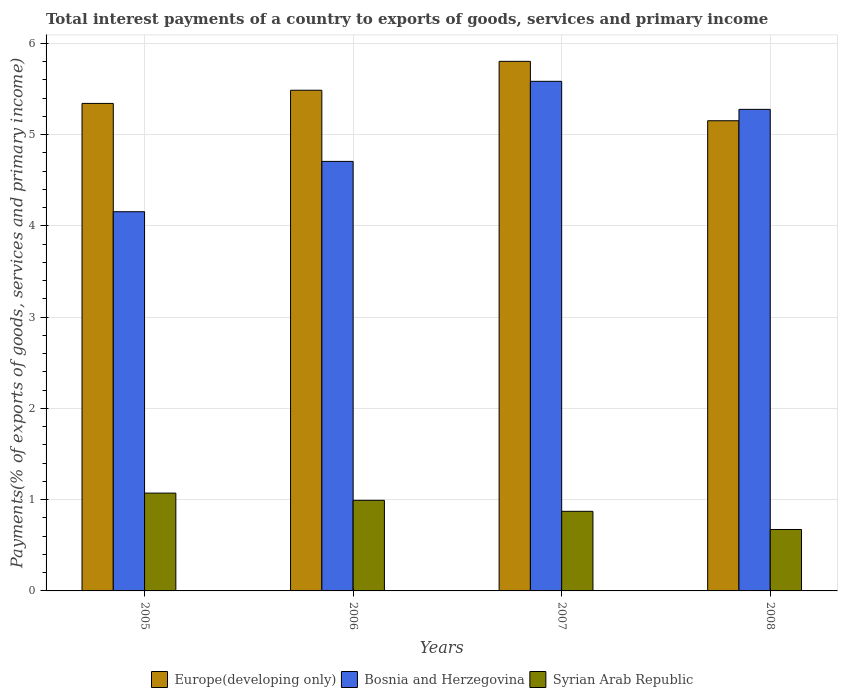Are the number of bars per tick equal to the number of legend labels?
Provide a short and direct response. Yes. How many bars are there on the 3rd tick from the right?
Keep it short and to the point. 3. What is the label of the 1st group of bars from the left?
Offer a terse response. 2005. What is the total interest payments in Syrian Arab Republic in 2005?
Give a very brief answer. 1.07. Across all years, what is the maximum total interest payments in Syrian Arab Republic?
Provide a short and direct response. 1.07. Across all years, what is the minimum total interest payments in Syrian Arab Republic?
Provide a short and direct response. 0.67. In which year was the total interest payments in Syrian Arab Republic maximum?
Offer a terse response. 2005. What is the total total interest payments in Syrian Arab Republic in the graph?
Give a very brief answer. 3.61. What is the difference between the total interest payments in Europe(developing only) in 2007 and that in 2008?
Your response must be concise. 0.65. What is the difference between the total interest payments in Europe(developing only) in 2007 and the total interest payments in Bosnia and Herzegovina in 2005?
Give a very brief answer. 1.65. What is the average total interest payments in Europe(developing only) per year?
Your response must be concise. 5.44. In the year 2008, what is the difference between the total interest payments in Syrian Arab Republic and total interest payments in Bosnia and Herzegovina?
Keep it short and to the point. -4.6. In how many years, is the total interest payments in Europe(developing only) greater than 3.4 %?
Give a very brief answer. 4. What is the ratio of the total interest payments in Europe(developing only) in 2005 to that in 2008?
Your response must be concise. 1.04. Is the total interest payments in Bosnia and Herzegovina in 2007 less than that in 2008?
Your response must be concise. No. Is the difference between the total interest payments in Syrian Arab Republic in 2006 and 2008 greater than the difference between the total interest payments in Bosnia and Herzegovina in 2006 and 2008?
Make the answer very short. Yes. What is the difference between the highest and the second highest total interest payments in Syrian Arab Republic?
Keep it short and to the point. 0.08. What is the difference between the highest and the lowest total interest payments in Bosnia and Herzegovina?
Provide a succinct answer. 1.43. In how many years, is the total interest payments in Syrian Arab Republic greater than the average total interest payments in Syrian Arab Republic taken over all years?
Offer a very short reply. 2. Is the sum of the total interest payments in Europe(developing only) in 2005 and 2008 greater than the maximum total interest payments in Bosnia and Herzegovina across all years?
Ensure brevity in your answer.  Yes. What does the 2nd bar from the left in 2005 represents?
Offer a terse response. Bosnia and Herzegovina. What does the 2nd bar from the right in 2006 represents?
Make the answer very short. Bosnia and Herzegovina. How many bars are there?
Provide a succinct answer. 12. How many years are there in the graph?
Provide a succinct answer. 4. Does the graph contain grids?
Keep it short and to the point. Yes. How are the legend labels stacked?
Offer a very short reply. Horizontal. What is the title of the graph?
Your answer should be compact. Total interest payments of a country to exports of goods, services and primary income. What is the label or title of the X-axis?
Provide a succinct answer. Years. What is the label or title of the Y-axis?
Offer a very short reply. Payments(% of exports of goods, services and primary income). What is the Payments(% of exports of goods, services and primary income) in Europe(developing only) in 2005?
Offer a terse response. 5.34. What is the Payments(% of exports of goods, services and primary income) of Bosnia and Herzegovina in 2005?
Your answer should be compact. 4.15. What is the Payments(% of exports of goods, services and primary income) in Syrian Arab Republic in 2005?
Offer a terse response. 1.07. What is the Payments(% of exports of goods, services and primary income) in Europe(developing only) in 2006?
Provide a short and direct response. 5.49. What is the Payments(% of exports of goods, services and primary income) in Bosnia and Herzegovina in 2006?
Make the answer very short. 4.71. What is the Payments(% of exports of goods, services and primary income) of Syrian Arab Republic in 2006?
Your answer should be compact. 0.99. What is the Payments(% of exports of goods, services and primary income) of Europe(developing only) in 2007?
Provide a short and direct response. 5.8. What is the Payments(% of exports of goods, services and primary income) of Bosnia and Herzegovina in 2007?
Your answer should be compact. 5.58. What is the Payments(% of exports of goods, services and primary income) in Syrian Arab Republic in 2007?
Provide a short and direct response. 0.87. What is the Payments(% of exports of goods, services and primary income) in Europe(developing only) in 2008?
Provide a short and direct response. 5.15. What is the Payments(% of exports of goods, services and primary income) in Bosnia and Herzegovina in 2008?
Keep it short and to the point. 5.28. What is the Payments(% of exports of goods, services and primary income) in Syrian Arab Republic in 2008?
Provide a succinct answer. 0.67. Across all years, what is the maximum Payments(% of exports of goods, services and primary income) in Europe(developing only)?
Provide a succinct answer. 5.8. Across all years, what is the maximum Payments(% of exports of goods, services and primary income) of Bosnia and Herzegovina?
Offer a very short reply. 5.58. Across all years, what is the maximum Payments(% of exports of goods, services and primary income) in Syrian Arab Republic?
Your answer should be very brief. 1.07. Across all years, what is the minimum Payments(% of exports of goods, services and primary income) in Europe(developing only)?
Your answer should be compact. 5.15. Across all years, what is the minimum Payments(% of exports of goods, services and primary income) in Bosnia and Herzegovina?
Provide a succinct answer. 4.15. Across all years, what is the minimum Payments(% of exports of goods, services and primary income) of Syrian Arab Republic?
Offer a very short reply. 0.67. What is the total Payments(% of exports of goods, services and primary income) of Europe(developing only) in the graph?
Make the answer very short. 21.78. What is the total Payments(% of exports of goods, services and primary income) of Bosnia and Herzegovina in the graph?
Your answer should be compact. 19.72. What is the total Payments(% of exports of goods, services and primary income) of Syrian Arab Republic in the graph?
Provide a succinct answer. 3.61. What is the difference between the Payments(% of exports of goods, services and primary income) in Europe(developing only) in 2005 and that in 2006?
Offer a terse response. -0.14. What is the difference between the Payments(% of exports of goods, services and primary income) in Bosnia and Herzegovina in 2005 and that in 2006?
Your answer should be compact. -0.55. What is the difference between the Payments(% of exports of goods, services and primary income) of Syrian Arab Republic in 2005 and that in 2006?
Offer a terse response. 0.08. What is the difference between the Payments(% of exports of goods, services and primary income) of Europe(developing only) in 2005 and that in 2007?
Offer a very short reply. -0.46. What is the difference between the Payments(% of exports of goods, services and primary income) in Bosnia and Herzegovina in 2005 and that in 2007?
Provide a short and direct response. -1.43. What is the difference between the Payments(% of exports of goods, services and primary income) in Syrian Arab Republic in 2005 and that in 2007?
Your answer should be very brief. 0.2. What is the difference between the Payments(% of exports of goods, services and primary income) in Europe(developing only) in 2005 and that in 2008?
Make the answer very short. 0.19. What is the difference between the Payments(% of exports of goods, services and primary income) of Bosnia and Herzegovina in 2005 and that in 2008?
Provide a succinct answer. -1.12. What is the difference between the Payments(% of exports of goods, services and primary income) in Syrian Arab Republic in 2005 and that in 2008?
Offer a very short reply. 0.4. What is the difference between the Payments(% of exports of goods, services and primary income) in Europe(developing only) in 2006 and that in 2007?
Your answer should be very brief. -0.32. What is the difference between the Payments(% of exports of goods, services and primary income) in Bosnia and Herzegovina in 2006 and that in 2007?
Offer a very short reply. -0.88. What is the difference between the Payments(% of exports of goods, services and primary income) in Syrian Arab Republic in 2006 and that in 2007?
Your answer should be compact. 0.12. What is the difference between the Payments(% of exports of goods, services and primary income) in Europe(developing only) in 2006 and that in 2008?
Ensure brevity in your answer.  0.33. What is the difference between the Payments(% of exports of goods, services and primary income) of Bosnia and Herzegovina in 2006 and that in 2008?
Offer a very short reply. -0.57. What is the difference between the Payments(% of exports of goods, services and primary income) of Syrian Arab Republic in 2006 and that in 2008?
Your response must be concise. 0.32. What is the difference between the Payments(% of exports of goods, services and primary income) of Europe(developing only) in 2007 and that in 2008?
Make the answer very short. 0.65. What is the difference between the Payments(% of exports of goods, services and primary income) of Bosnia and Herzegovina in 2007 and that in 2008?
Your answer should be very brief. 0.31. What is the difference between the Payments(% of exports of goods, services and primary income) of Syrian Arab Republic in 2007 and that in 2008?
Provide a short and direct response. 0.2. What is the difference between the Payments(% of exports of goods, services and primary income) in Europe(developing only) in 2005 and the Payments(% of exports of goods, services and primary income) in Bosnia and Herzegovina in 2006?
Your answer should be compact. 0.64. What is the difference between the Payments(% of exports of goods, services and primary income) of Europe(developing only) in 2005 and the Payments(% of exports of goods, services and primary income) of Syrian Arab Republic in 2006?
Your response must be concise. 4.35. What is the difference between the Payments(% of exports of goods, services and primary income) of Bosnia and Herzegovina in 2005 and the Payments(% of exports of goods, services and primary income) of Syrian Arab Republic in 2006?
Offer a terse response. 3.16. What is the difference between the Payments(% of exports of goods, services and primary income) in Europe(developing only) in 2005 and the Payments(% of exports of goods, services and primary income) in Bosnia and Herzegovina in 2007?
Ensure brevity in your answer.  -0.24. What is the difference between the Payments(% of exports of goods, services and primary income) in Europe(developing only) in 2005 and the Payments(% of exports of goods, services and primary income) in Syrian Arab Republic in 2007?
Your answer should be very brief. 4.47. What is the difference between the Payments(% of exports of goods, services and primary income) in Bosnia and Herzegovina in 2005 and the Payments(% of exports of goods, services and primary income) in Syrian Arab Republic in 2007?
Ensure brevity in your answer.  3.28. What is the difference between the Payments(% of exports of goods, services and primary income) of Europe(developing only) in 2005 and the Payments(% of exports of goods, services and primary income) of Bosnia and Herzegovina in 2008?
Make the answer very short. 0.07. What is the difference between the Payments(% of exports of goods, services and primary income) of Europe(developing only) in 2005 and the Payments(% of exports of goods, services and primary income) of Syrian Arab Republic in 2008?
Your response must be concise. 4.67. What is the difference between the Payments(% of exports of goods, services and primary income) in Bosnia and Herzegovina in 2005 and the Payments(% of exports of goods, services and primary income) in Syrian Arab Republic in 2008?
Give a very brief answer. 3.48. What is the difference between the Payments(% of exports of goods, services and primary income) of Europe(developing only) in 2006 and the Payments(% of exports of goods, services and primary income) of Bosnia and Herzegovina in 2007?
Your answer should be very brief. -0.1. What is the difference between the Payments(% of exports of goods, services and primary income) of Europe(developing only) in 2006 and the Payments(% of exports of goods, services and primary income) of Syrian Arab Republic in 2007?
Provide a succinct answer. 4.61. What is the difference between the Payments(% of exports of goods, services and primary income) of Bosnia and Herzegovina in 2006 and the Payments(% of exports of goods, services and primary income) of Syrian Arab Republic in 2007?
Make the answer very short. 3.83. What is the difference between the Payments(% of exports of goods, services and primary income) of Europe(developing only) in 2006 and the Payments(% of exports of goods, services and primary income) of Bosnia and Herzegovina in 2008?
Offer a terse response. 0.21. What is the difference between the Payments(% of exports of goods, services and primary income) in Europe(developing only) in 2006 and the Payments(% of exports of goods, services and primary income) in Syrian Arab Republic in 2008?
Keep it short and to the point. 4.81. What is the difference between the Payments(% of exports of goods, services and primary income) in Bosnia and Herzegovina in 2006 and the Payments(% of exports of goods, services and primary income) in Syrian Arab Republic in 2008?
Provide a succinct answer. 4.03. What is the difference between the Payments(% of exports of goods, services and primary income) of Europe(developing only) in 2007 and the Payments(% of exports of goods, services and primary income) of Bosnia and Herzegovina in 2008?
Offer a terse response. 0.53. What is the difference between the Payments(% of exports of goods, services and primary income) of Europe(developing only) in 2007 and the Payments(% of exports of goods, services and primary income) of Syrian Arab Republic in 2008?
Offer a very short reply. 5.13. What is the difference between the Payments(% of exports of goods, services and primary income) in Bosnia and Herzegovina in 2007 and the Payments(% of exports of goods, services and primary income) in Syrian Arab Republic in 2008?
Ensure brevity in your answer.  4.91. What is the average Payments(% of exports of goods, services and primary income) of Europe(developing only) per year?
Offer a very short reply. 5.44. What is the average Payments(% of exports of goods, services and primary income) of Bosnia and Herzegovina per year?
Your response must be concise. 4.93. What is the average Payments(% of exports of goods, services and primary income) of Syrian Arab Republic per year?
Give a very brief answer. 0.9. In the year 2005, what is the difference between the Payments(% of exports of goods, services and primary income) of Europe(developing only) and Payments(% of exports of goods, services and primary income) of Bosnia and Herzegovina?
Your answer should be compact. 1.19. In the year 2005, what is the difference between the Payments(% of exports of goods, services and primary income) of Europe(developing only) and Payments(% of exports of goods, services and primary income) of Syrian Arab Republic?
Your answer should be compact. 4.27. In the year 2005, what is the difference between the Payments(% of exports of goods, services and primary income) of Bosnia and Herzegovina and Payments(% of exports of goods, services and primary income) of Syrian Arab Republic?
Your answer should be compact. 3.08. In the year 2006, what is the difference between the Payments(% of exports of goods, services and primary income) of Europe(developing only) and Payments(% of exports of goods, services and primary income) of Bosnia and Herzegovina?
Your answer should be very brief. 0.78. In the year 2006, what is the difference between the Payments(% of exports of goods, services and primary income) of Europe(developing only) and Payments(% of exports of goods, services and primary income) of Syrian Arab Republic?
Offer a terse response. 4.49. In the year 2006, what is the difference between the Payments(% of exports of goods, services and primary income) of Bosnia and Herzegovina and Payments(% of exports of goods, services and primary income) of Syrian Arab Republic?
Keep it short and to the point. 3.71. In the year 2007, what is the difference between the Payments(% of exports of goods, services and primary income) in Europe(developing only) and Payments(% of exports of goods, services and primary income) in Bosnia and Herzegovina?
Keep it short and to the point. 0.22. In the year 2007, what is the difference between the Payments(% of exports of goods, services and primary income) in Europe(developing only) and Payments(% of exports of goods, services and primary income) in Syrian Arab Republic?
Offer a terse response. 4.93. In the year 2007, what is the difference between the Payments(% of exports of goods, services and primary income) of Bosnia and Herzegovina and Payments(% of exports of goods, services and primary income) of Syrian Arab Republic?
Offer a terse response. 4.71. In the year 2008, what is the difference between the Payments(% of exports of goods, services and primary income) of Europe(developing only) and Payments(% of exports of goods, services and primary income) of Bosnia and Herzegovina?
Provide a short and direct response. -0.12. In the year 2008, what is the difference between the Payments(% of exports of goods, services and primary income) in Europe(developing only) and Payments(% of exports of goods, services and primary income) in Syrian Arab Republic?
Your answer should be very brief. 4.48. In the year 2008, what is the difference between the Payments(% of exports of goods, services and primary income) in Bosnia and Herzegovina and Payments(% of exports of goods, services and primary income) in Syrian Arab Republic?
Offer a terse response. 4.6. What is the ratio of the Payments(% of exports of goods, services and primary income) of Europe(developing only) in 2005 to that in 2006?
Your answer should be compact. 0.97. What is the ratio of the Payments(% of exports of goods, services and primary income) in Bosnia and Herzegovina in 2005 to that in 2006?
Offer a very short reply. 0.88. What is the ratio of the Payments(% of exports of goods, services and primary income) in Syrian Arab Republic in 2005 to that in 2006?
Provide a short and direct response. 1.08. What is the ratio of the Payments(% of exports of goods, services and primary income) in Europe(developing only) in 2005 to that in 2007?
Make the answer very short. 0.92. What is the ratio of the Payments(% of exports of goods, services and primary income) of Bosnia and Herzegovina in 2005 to that in 2007?
Keep it short and to the point. 0.74. What is the ratio of the Payments(% of exports of goods, services and primary income) of Syrian Arab Republic in 2005 to that in 2007?
Keep it short and to the point. 1.23. What is the ratio of the Payments(% of exports of goods, services and primary income) of Europe(developing only) in 2005 to that in 2008?
Keep it short and to the point. 1.04. What is the ratio of the Payments(% of exports of goods, services and primary income) in Bosnia and Herzegovina in 2005 to that in 2008?
Give a very brief answer. 0.79. What is the ratio of the Payments(% of exports of goods, services and primary income) in Syrian Arab Republic in 2005 to that in 2008?
Your answer should be compact. 1.59. What is the ratio of the Payments(% of exports of goods, services and primary income) in Europe(developing only) in 2006 to that in 2007?
Your answer should be compact. 0.95. What is the ratio of the Payments(% of exports of goods, services and primary income) of Bosnia and Herzegovina in 2006 to that in 2007?
Offer a terse response. 0.84. What is the ratio of the Payments(% of exports of goods, services and primary income) in Syrian Arab Republic in 2006 to that in 2007?
Provide a short and direct response. 1.14. What is the ratio of the Payments(% of exports of goods, services and primary income) of Europe(developing only) in 2006 to that in 2008?
Offer a terse response. 1.06. What is the ratio of the Payments(% of exports of goods, services and primary income) of Bosnia and Herzegovina in 2006 to that in 2008?
Your answer should be compact. 0.89. What is the ratio of the Payments(% of exports of goods, services and primary income) of Syrian Arab Republic in 2006 to that in 2008?
Give a very brief answer. 1.48. What is the ratio of the Payments(% of exports of goods, services and primary income) in Europe(developing only) in 2007 to that in 2008?
Your answer should be very brief. 1.13. What is the ratio of the Payments(% of exports of goods, services and primary income) in Bosnia and Herzegovina in 2007 to that in 2008?
Make the answer very short. 1.06. What is the ratio of the Payments(% of exports of goods, services and primary income) in Syrian Arab Republic in 2007 to that in 2008?
Offer a terse response. 1.3. What is the difference between the highest and the second highest Payments(% of exports of goods, services and primary income) of Europe(developing only)?
Offer a terse response. 0.32. What is the difference between the highest and the second highest Payments(% of exports of goods, services and primary income) of Bosnia and Herzegovina?
Your response must be concise. 0.31. What is the difference between the highest and the second highest Payments(% of exports of goods, services and primary income) of Syrian Arab Republic?
Your answer should be very brief. 0.08. What is the difference between the highest and the lowest Payments(% of exports of goods, services and primary income) of Europe(developing only)?
Give a very brief answer. 0.65. What is the difference between the highest and the lowest Payments(% of exports of goods, services and primary income) in Bosnia and Herzegovina?
Offer a very short reply. 1.43. What is the difference between the highest and the lowest Payments(% of exports of goods, services and primary income) in Syrian Arab Republic?
Provide a short and direct response. 0.4. 